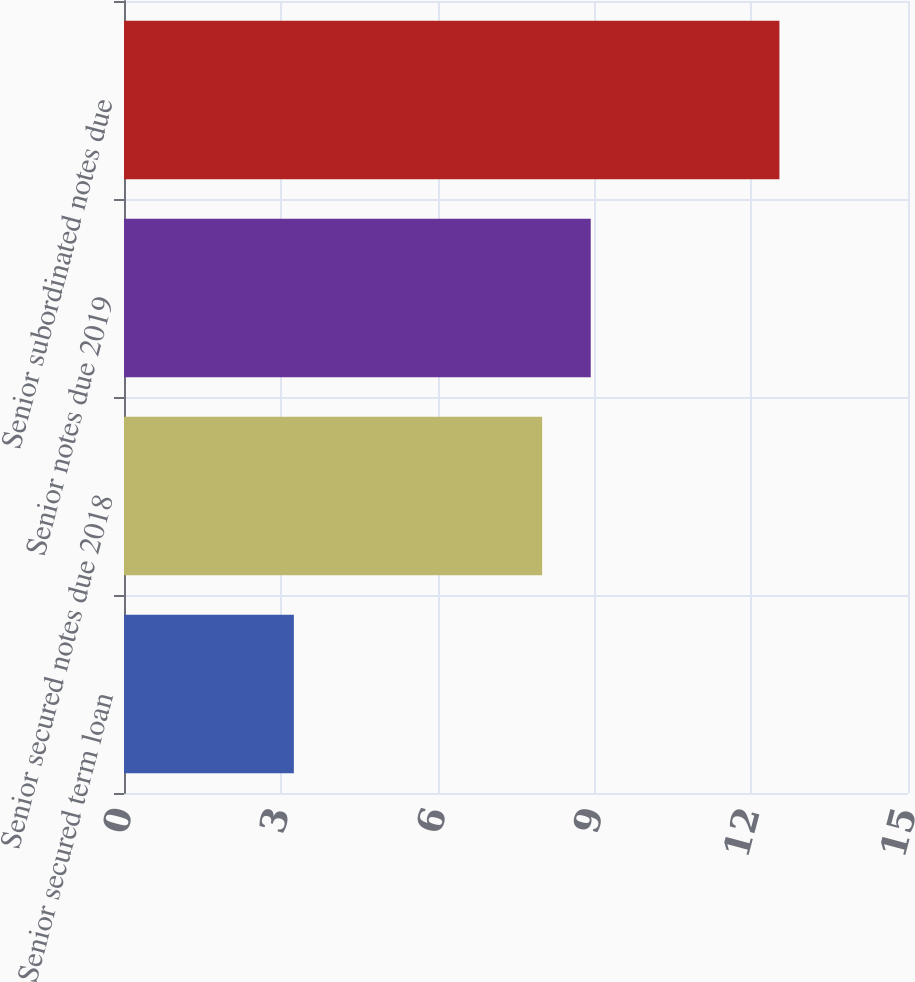<chart> <loc_0><loc_0><loc_500><loc_500><bar_chart><fcel>Senior secured term loan<fcel>Senior secured notes due 2018<fcel>Senior notes due 2019<fcel>Senior subordinated notes due<nl><fcel>3.25<fcel>8<fcel>8.93<fcel>12.54<nl></chart> 